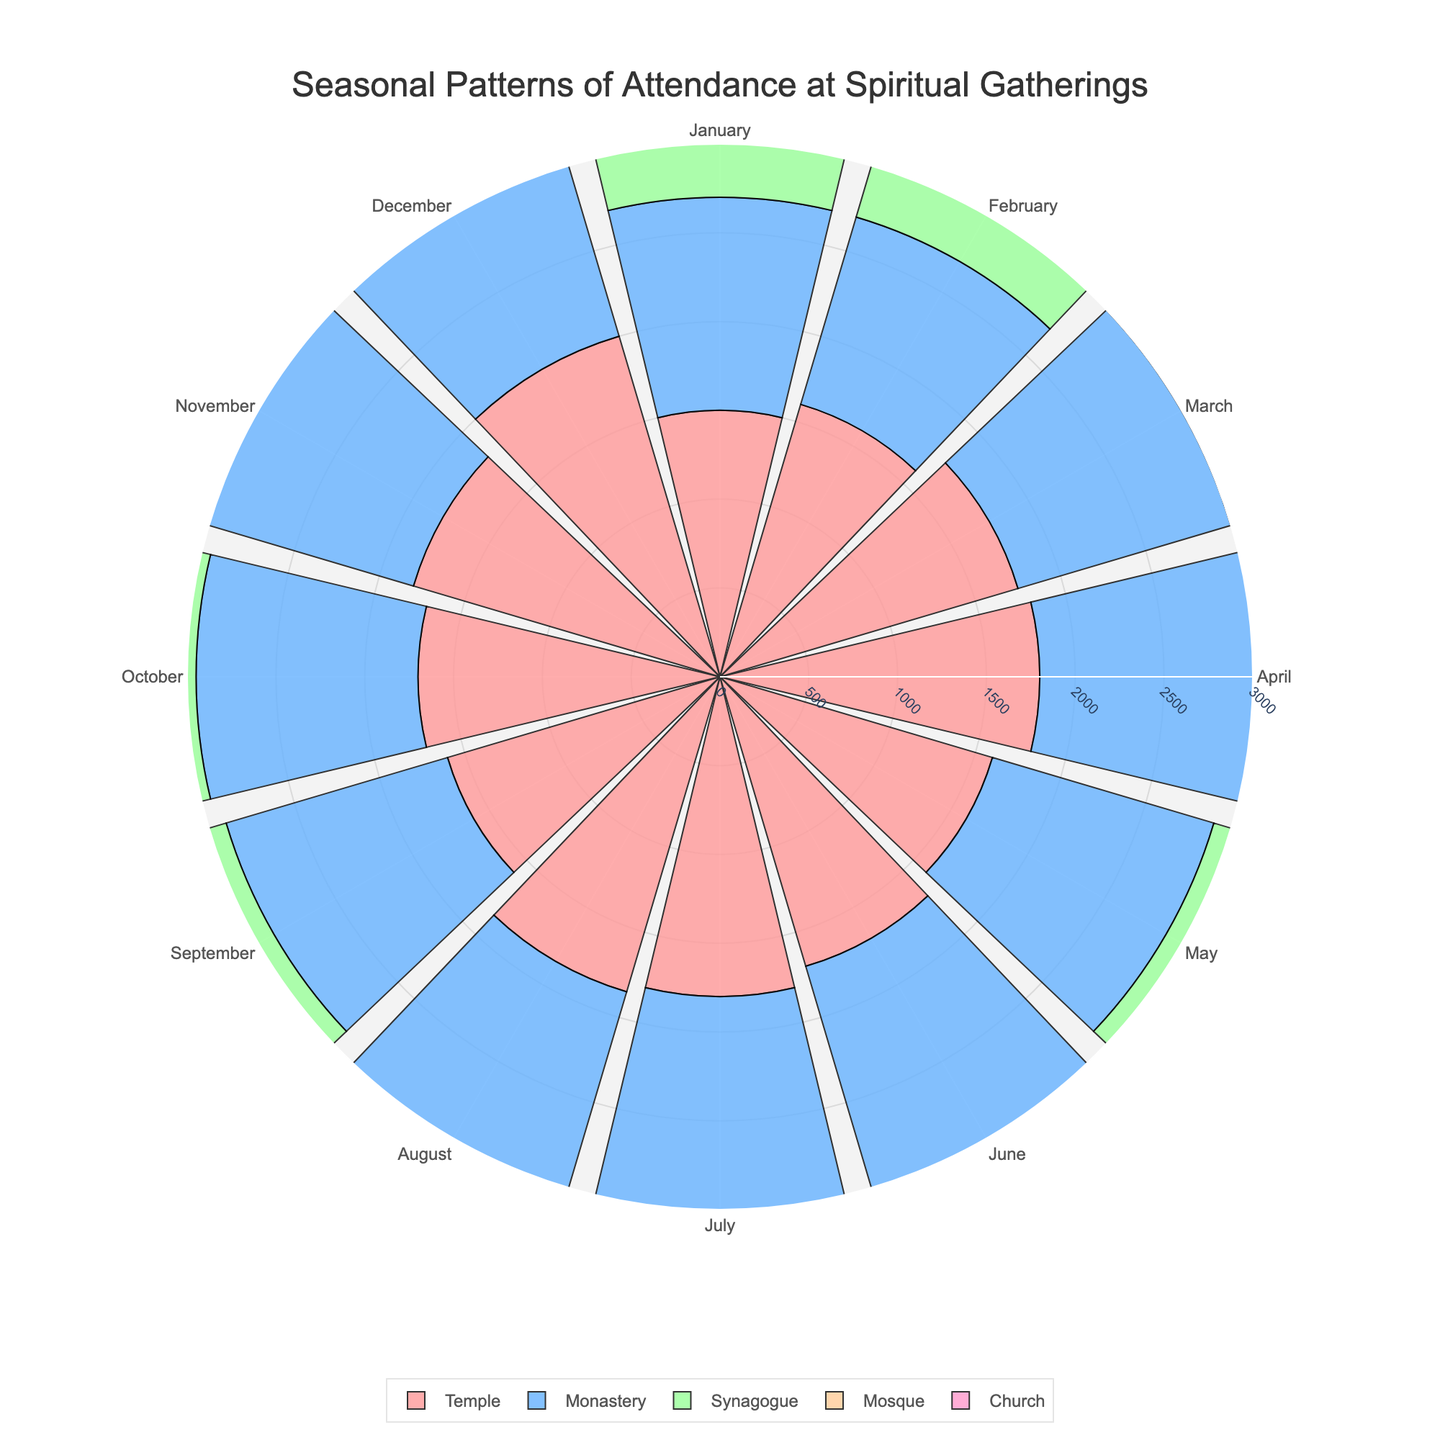Which month has the highest attendance at the Church? The highest attendance at the Church can be observed at the top of the radial axis circle. According to the chart, December shows the highest value for the Church with an attendance of 2700.
Answer: December Which venue had the lowest attendance in February? To determine the lowest attendance in February, locate the February segment on the angular axis and compare the radial heights of each venue's bar. The Monastery has the shortest bar length with an attendance of 1100.
Answer: Monastery What is the range of attendance at the Mosque throughout the year? The range of attendance is the difference between the maximum and minimum values. The highest attendance at the Mosque is 2100 in December, and the lowest is 1750 in February. Therefore, the range is 2100 - 1750 = 350.
Answer: 350 How does the attendance at the Temple in January compare to July? To compare the attendance, look at the radial lengths for January and July segments for the Temple. January shows an attendance of 1500, while July shows an attendance of 1800. Hence, July has a higher attendance than January.
Answer: July has higher attendance Which venue exhibits the most stable attendance throughout the year? Stable attendance is indicated by relatively equal radial bar lengths across months. The Church shows the most stable attendance with values varying in a smaller range compared to other venues.
Answer: Church What is the average attendance at the Synagogue in the first quarter (January to March)? To find the average attendance for January to March, sum the attendance values and divide by the number of months. The Synagogue attendance values are 1300 (Jan), 1400 (Feb), and 1500 (Mar). (1300 + 1400 + 1500) / 3 = 1400.
Answer: 1400 Which month shows the lowest combined attendance for all venues? To determine the lowest combined attendance, sum the attendance values for each month and compare. January has the lowest combined attendance: 1500 (Temple) + 1200 (Monastery) + 1300 (Synagogue) + 1800 (Mosque) + 2200 (Church) = 8000.
Answer: January How does the synagogue's attendance in December compare with that of the temple in the same month? Locate the December segment on the angular axis for both venues. Synagogue attendance is 1800 and Temple attendance is 2000, so the Temple has a higher attendance in December.
Answer: Temple has higher attendance What is the trend of attendance at the Monastery from January to December? To identify the trend, observe the bar lengths for the Monastery from January to December. The attendance generally increases with minor fluctuations, from 1200 in January to 1500 in December.
Answer: Increasing trend with fluctuations What is the total attendance at the Church for the second half of the year (July to December)? Sum the attendance values for the Church from July to December: 2300 (July) + 2600 (August) + 2500 (September) + 2400 (October) + 2500 (November) + 2700 (December) = 15000.
Answer: 15000 